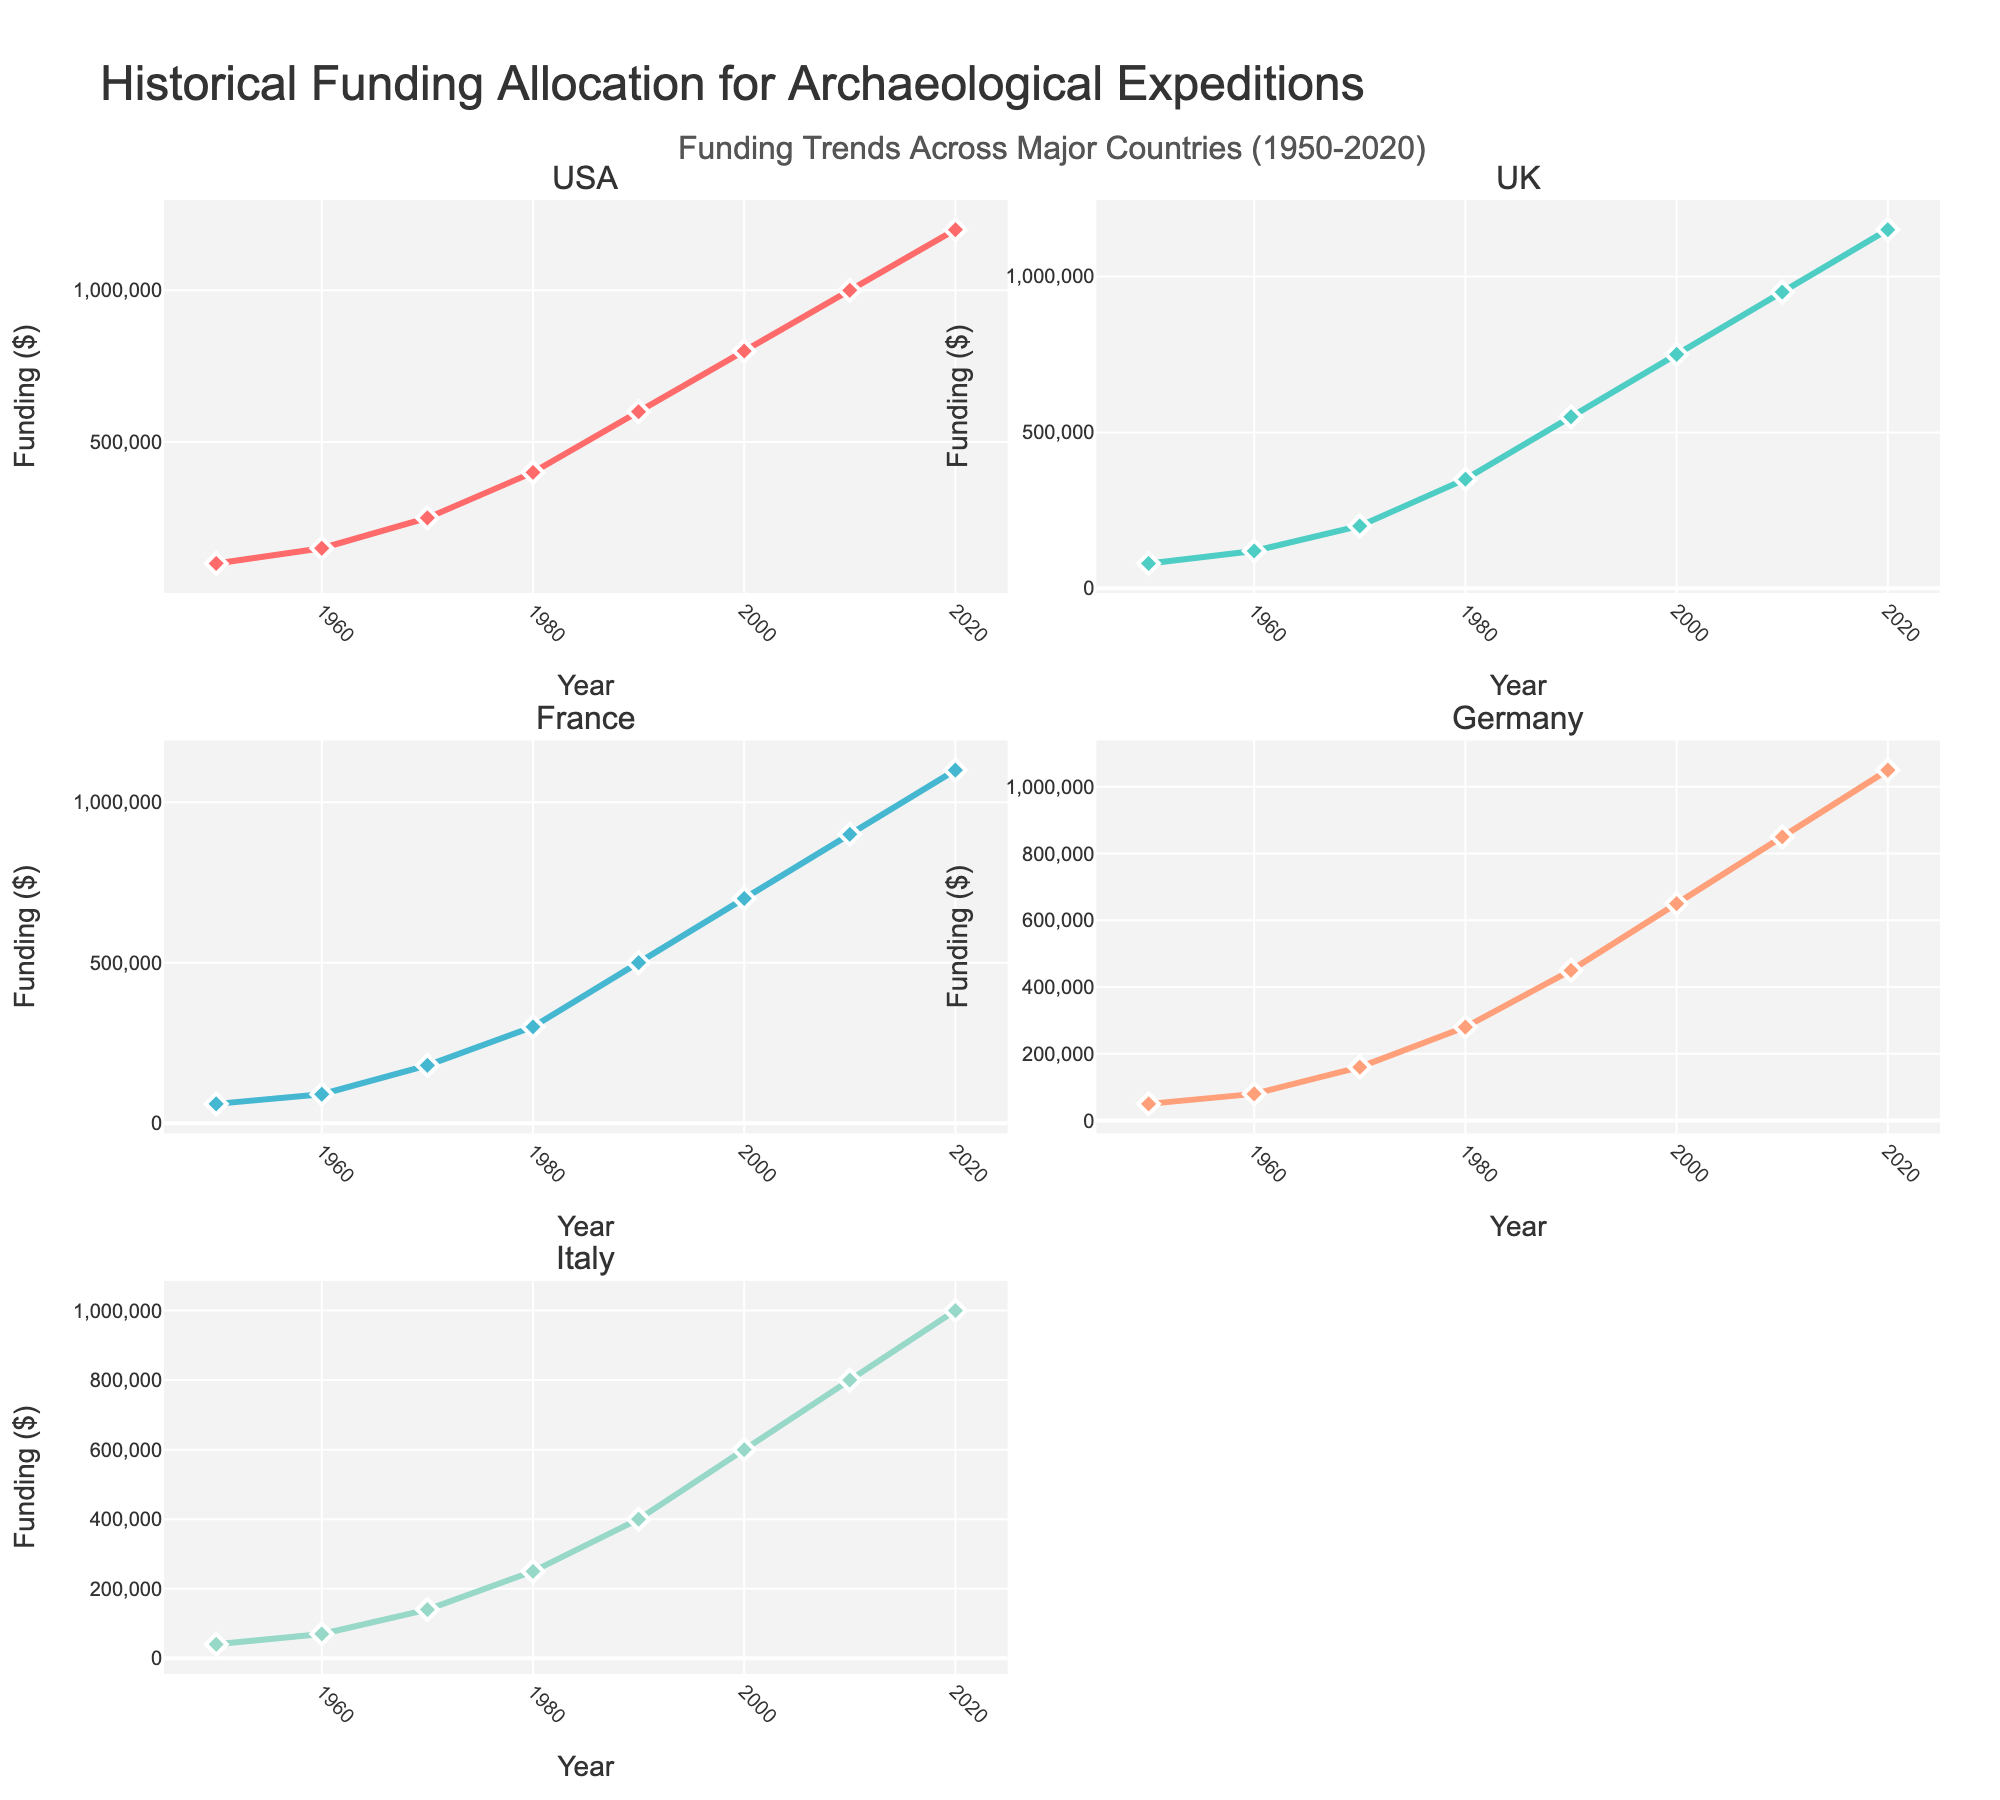What's the title of the figure? The title is prominently displayed at the top of the figure.
Answer: Crop Yield Analysis: Weather Patterns and Planting Dates How many different seasons are represented in the figure? By examining the color-coded points across the scatter plot matrix, we can see distinct markers for Spring 2021, Summer 2021, Fall 2021, Spring 2022, Summer 2022, Fall 2022, Spring 2023, Summer 2023, and Fall 2023.
Answer: 9 What's the range of the Crop Yield values? The Crop Yield values can be observed along the axes of the matrix. The histogram on the diagonal for Crop Yield helps to identify the range. These values vary from 6.5 to 7.5.
Answer: 6.5 to 7.5 Which variable shows the highest value of Crop Yield? By cross-referencing the Crop Yield with other variables using the scatterplot matrix, the highest yield (7.5) appears when Avg Temperature is around 19.2 in Spring 2022.
Answer: Avg Temperature - Spring 2022 How is Rainfall related to Crop Yield? Observing the scatterplots where Crop Yield and Rainfall are plotted, there's no clear linear relationship. The points are scattered, suggesting a more complex relationship or possible influence of other factors.
Answer: Complex, no clear linear relationship Which season has the lowest average temperature? By looking at the scatter plots and histograms for Avg Temperature, Spring 2021 has the lowest recorded average temperature of 18.5.
Answer: Spring 2021 What's the difference in average temperature between Summer 2021 and Summer 2022? The scatter plots show Summer 2021 has Avg Temperature of 27.3 and Summer 2022 of 28.1. The difference is calculated as 28.1 - 27.3.
Answer: 0.8 Is there a season where higher rainfall and higher Crop Yield both occur? By looking at the scatter plots for Rainfall and Crop Yield, Spring 2022 stands out with higher values of rainfall and one of the highest Crop Yields.
Answer: Spring 2022 Which season had the maximum Sunshine Hours, and what was the corresponding Crop Yield? Looking at the scatterplots where Sunshine Hours are plotted along with the Crop Yield, Summer 2022 had the maximum Sunshine Hours (330 hours) with a corresponding Crop Yield of 6.9.
Answer: Summer 2022 - 6.9 